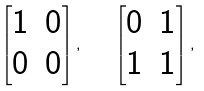<formula> <loc_0><loc_0><loc_500><loc_500>\begin{bmatrix} 1 & 0 \\ 0 & 0 \end{bmatrix} , \quad \begin{bmatrix} 0 & 1 \\ 1 & 1 \end{bmatrix} ,</formula> 